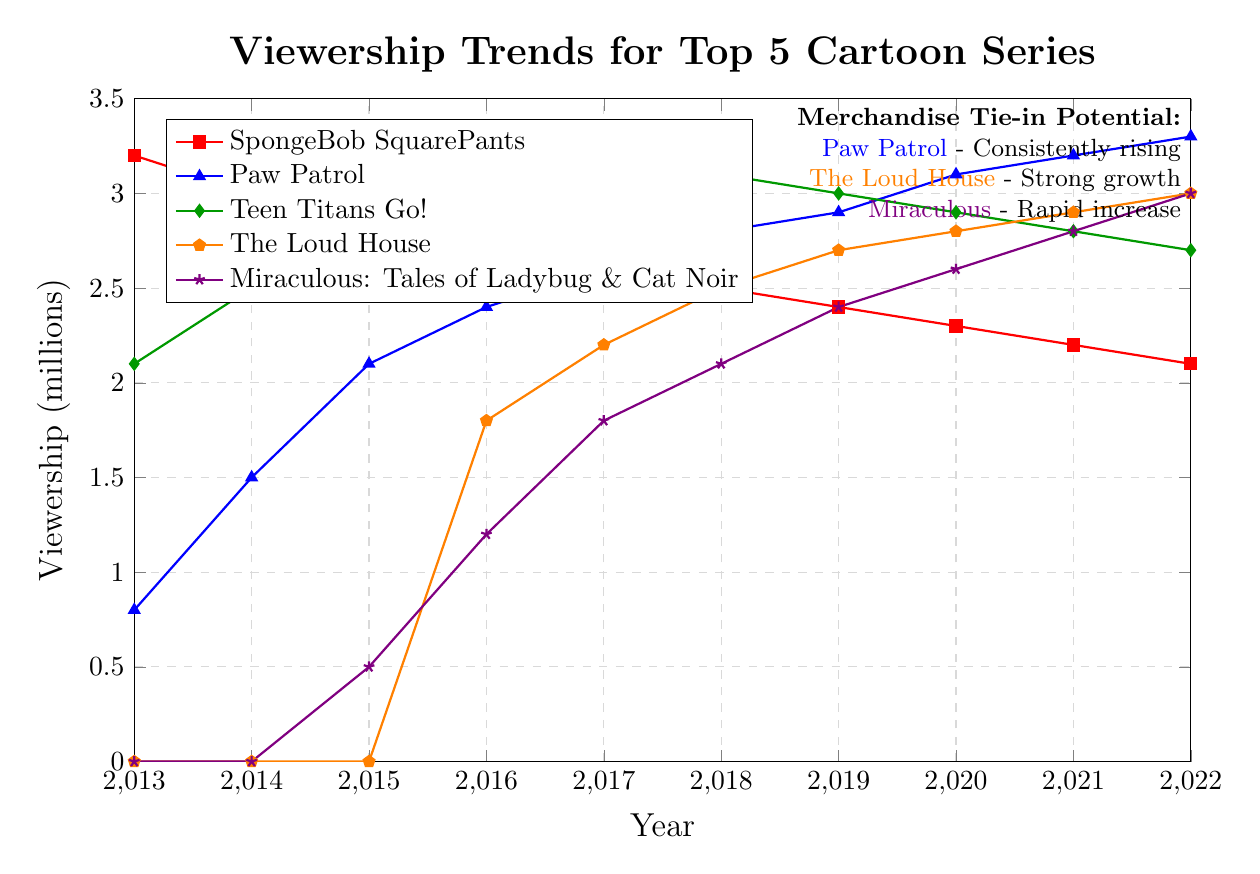Which cartoon had the highest viewership in 2013? The highest viewership in 2013 can be seen for "SpongeBob SquarePants" as it starts at 3.2 million, which is the highest among all the cartoons.
Answer: SpongeBob SquarePants Which series showed consistent growth over the decade? By examining the trends, "Paw Patrol" and "The Loud House" exhibit consistent growth from 2013 to 2022. "Paw Patrol" starts at 0.8 million in 2013 and grows to 3.3 million in 2022. "The Loud House" starts showing viewership in 2016 at 1.8 million and reaches 3.0 million by 2022.
Answer: Paw Patrol, The Loud House What is the average viewership for Teen Titans Go! from 2013 to 2022? Summing the viewership of Teen Titans Go! from 2013 to 2022: 2.1 + 2.5 + 2.7 + 2.8 + 3 + 3.1 + 3.0 + 2.9 + 2.8 + 2.7 = 27.6 million. Dividing by the number of years (10) gives an average of 27.6 / 10 = 2.76 million.
Answer: 2.76 million Which cartoon had the most significant decline in viewership over the decade? "SpongeBob SquarePants" starts at 3.2 million in 2013 and decreases to 2.1 million in 2022. This 1.1 million decline is the most significant compared to the other series.
Answer: SpongeBob SquarePants How does the viewership of Miraculous: Tales of Ladybug & Cat Noir compare to The Loud House in 2020? In 2020, Miraculous: Tales of Ladybug & Cat Noir has a viewership of 2.6 million, while The Loud House has a viewership of 2.8 million. The Loud House has a higher viewership by 0.2 million.
Answer: The Loud House is higher What is the combined viewership for all cartoons in 2022? Summing up the viewership for all cartoons in 2022: SpongeBob SquarePants (2.1) + Paw Patrol (3.3) + Teen Titans Go! (2.7) + The Loud House (3.0) + Miraculous: Tales of Ladybug & Cat Noir (3.0) = 14.1 million.
Answer: 14.1 million In which year did The Loud House surpass a viewership of 2.5 million? The viewership of The Loud House surpasses 2.5 million in 2018, where it recorded a viewership of 2.5 million, then increasing further in the following years.
Answer: 2018 